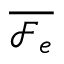<formula> <loc_0><loc_0><loc_500><loc_500>\overline { { \mathcal { F } _ { e } } }</formula> 